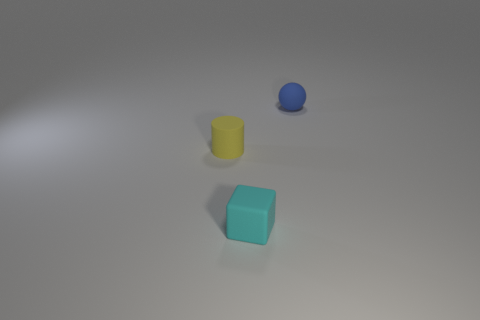Describe the arrangement of objects in the image. There are three objects in the image, positioned on a flat surface. From the perspective of the viewer, there is a yellow cylindrical object on the left, a cyan cube in the center, and a smaller blue spherical object to the right. The layout appears intentional, with an emphasis on geometry and color contrast, creating a visually balanced composition. 